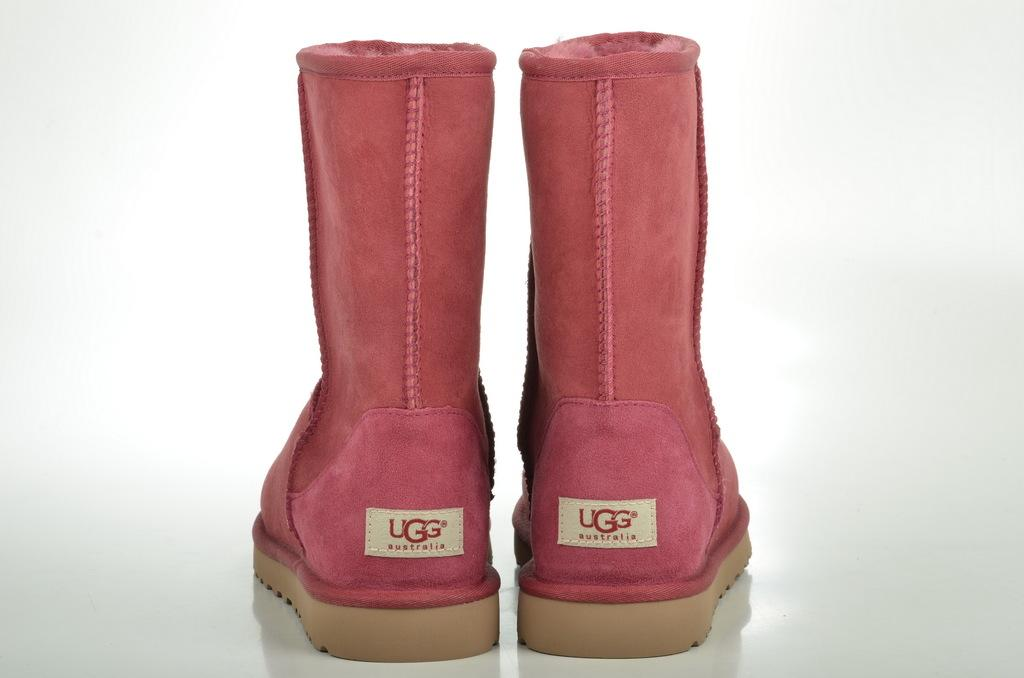What type of footwear is visible in the image? There is a pair of footwear in the image. What color is the background of the image? The background of the image is white. What type of roof can be seen on the church in the image? There is no roof or church present in the image; it only features a pair of footwear and a white background. 